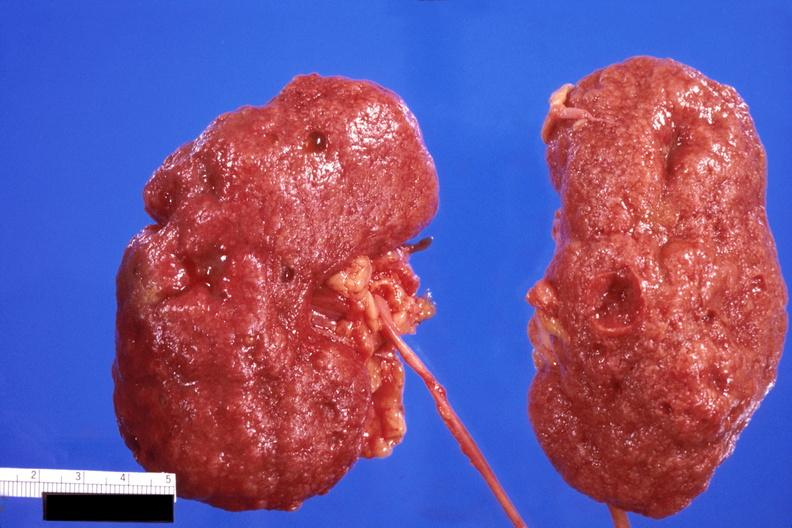does this image show kidney, cortical scarring from diabetes mellitus?
Answer the question using a single word or phrase. Yes 